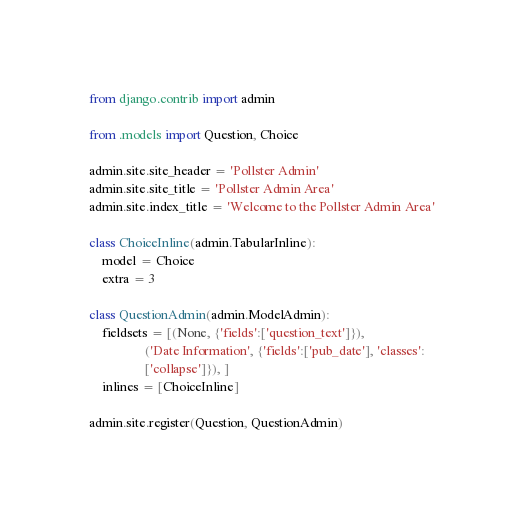<code> <loc_0><loc_0><loc_500><loc_500><_Python_>from django.contrib import admin

from .models import Question, Choice

admin.site.site_header = 'Pollster Admin'
admin.site.site_title = 'Pollster Admin Area'
admin.site.index_title = 'Welcome to the Pollster Admin Area'

class ChoiceInline(admin.TabularInline):
    model = Choice
    extra = 3

class QuestionAdmin(admin.ModelAdmin):
    fieldsets = [(None, {'fields':['question_text']}),
                 ('Date Information', {'fields':['pub_date'], 'classes':
                 ['collapse']}), ]
    inlines = [ChoiceInline]

admin.site.register(Question, QuestionAdmin)
</code> 